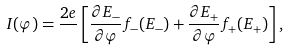<formula> <loc_0><loc_0><loc_500><loc_500>I ( \varphi ) = \frac { 2 e } { } \left [ \frac { \partial E _ { - } } { \partial \varphi } f _ { - } ( E _ { - } ) + \frac { \partial E _ { + } } { \partial \varphi } f _ { + } ( E _ { + } ) \right ] ,</formula> 